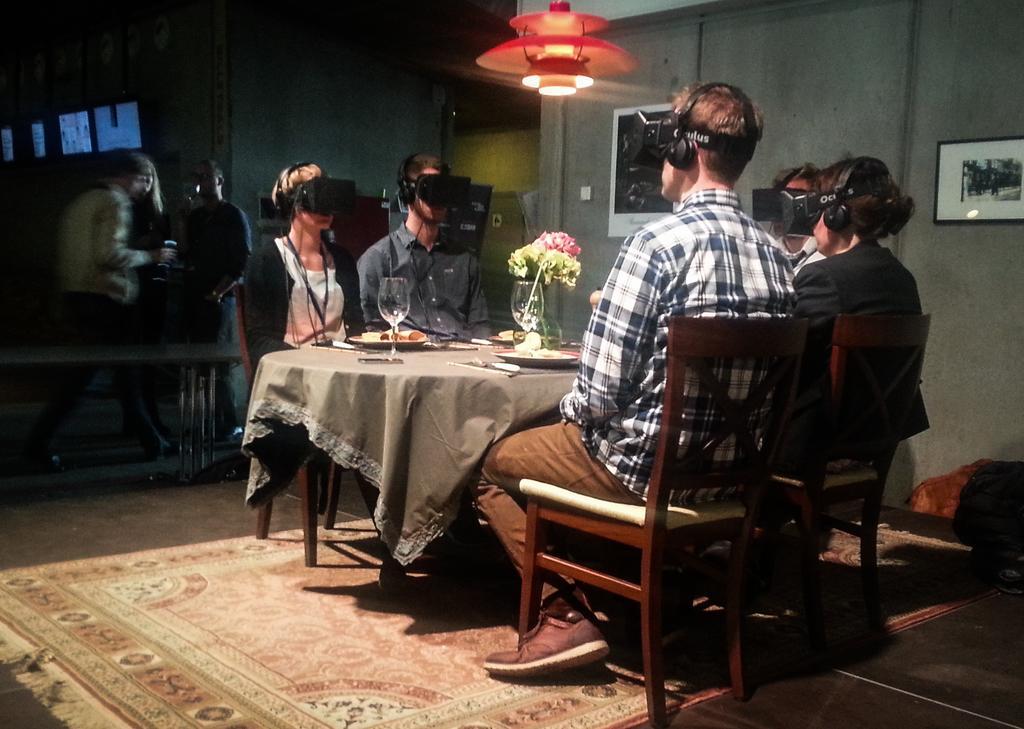Describe this image in one or two sentences. Here we can see a group of people are sitting on the chair, and in front here is the table and plates and flower vase on it, and at above here is the light, and here is the wall and photo frames on it. 